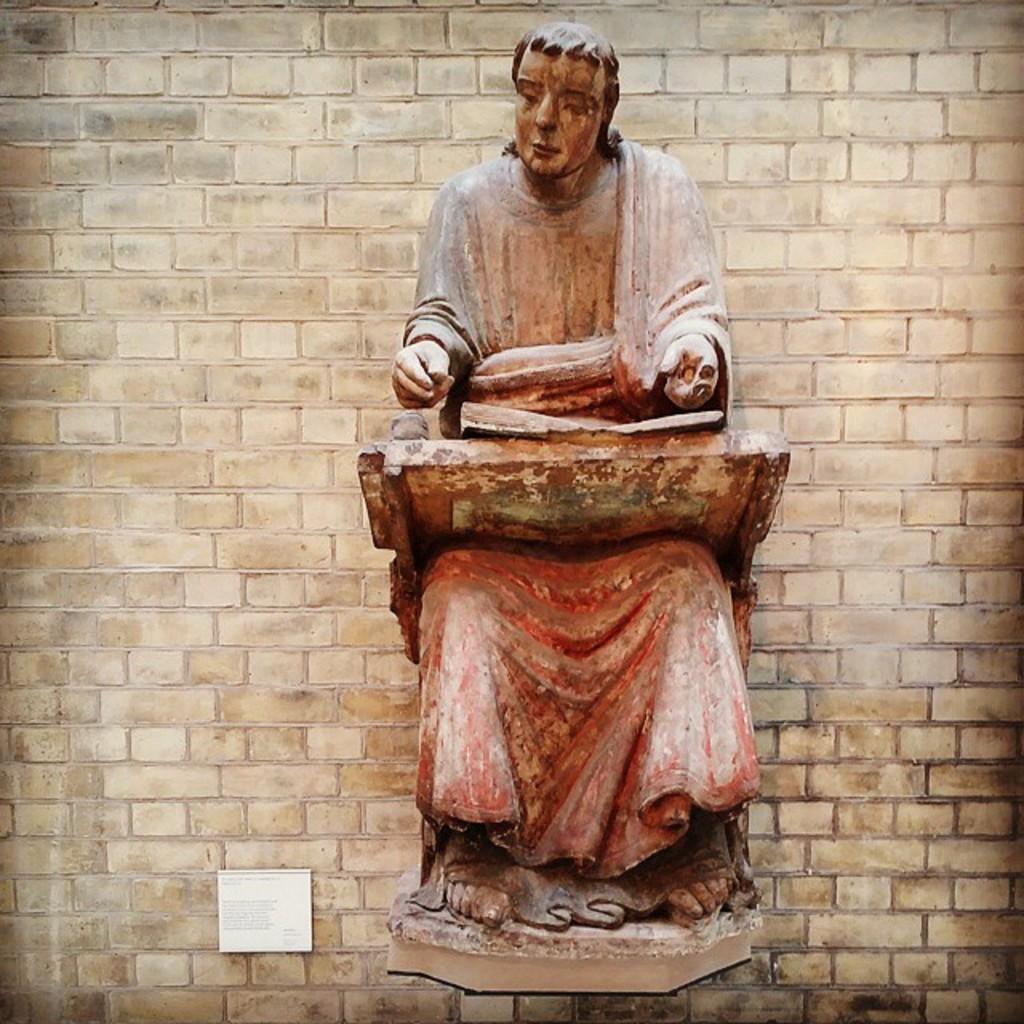Describe this image in one or two sentences. In this image I can see a statue, a white board and a cream colour wall in the background. I can also see something is written on this board. 